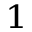<formula> <loc_0><loc_0><loc_500><loc_500>^ { 1 }</formula> 